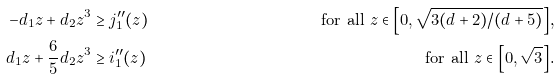Convert formula to latex. <formula><loc_0><loc_0><loc_500><loc_500>- d _ { 1 } z + d _ { 2 } z ^ { 3 } & \geq j _ { 1 } ^ { \prime \prime } ( z ) & \text {for all $z\in\left[0,\sqrt{3(d+2)/(d+5)}\right]$,} \\ d _ { 1 } z + \frac { 6 } { 5 } d _ { 2 } z ^ { 3 } & \geq i _ { 1 } ^ { \prime \prime } ( z ) & \text {for all $z\in\left[0,\sqrt{3}\right]$.}</formula> 